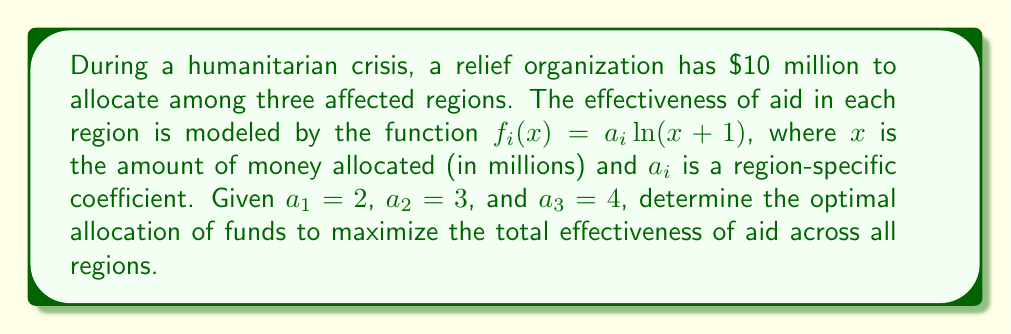Can you answer this question? To solve this problem, we'll use the method of Lagrange multipliers, as we're maximizing a function subject to a constraint.

1) Let $x$, $y$, and $z$ be the amounts allocated to regions 1, 2, and 3 respectively.

2) Our objective function is:
   $$f(x,y,z) = 2\ln(x+1) + 3\ln(y+1) + 4\ln(z+1)$$

3) Our constraint is:
   $$g(x,y,z) = x + y + z - 10 = 0$$

4) We form the Lagrangian:
   $$L(x,y,z,\lambda) = 2\ln(x+1) + 3\ln(y+1) + 4\ln(z+1) - \lambda(x + y + z - 10)$$

5) We take partial derivatives and set them to zero:
   $$\frac{\partial L}{\partial x} = \frac{2}{x+1} - \lambda = 0$$
   $$\frac{\partial L}{\partial y} = \frac{3}{y+1} - \lambda = 0$$
   $$\frac{\partial L}{\partial z} = \frac{4}{z+1} - \lambda = 0$$
   $$\frac{\partial L}{\partial \lambda} = x + y + z - 10 = 0$$

6) From these equations, we can deduce:
   $$\frac{2}{x+1} = \frac{3}{y+1} = \frac{4}{z+1} = \lambda$$

7) This implies:
   $$x+1 = \frac{2}{\lambda}, y+1 = \frac{3}{\lambda}, z+1 = \frac{4}{\lambda}$$

8) Substituting into the constraint equation:
   $$(\frac{2}{\lambda} - 1) + (\frac{3}{\lambda} - 1) + (\frac{4}{\lambda} - 1) = 10$$
   $$\frac{9}{\lambda} - 3 = 10$$
   $$\frac{9}{\lambda} = 13$$
   $$\lambda = \frac{9}{13}$$

9) Now we can solve for $x$, $y$, and $z$:
   $$x = \frac{2}{\lambda} - 1 = \frac{26}{9} - 1 = \frac{17}{9} \approx 1.89$$
   $$y = \frac{3}{\lambda} - 1 = \frac{39}{9} - 1 = \frac{30}{9} \approx 3.33$$
   $$z = \frac{4}{\lambda} - 1 = \frac{52}{9} - 1 = \frac{43}{9} \approx 4.78$$

10) We can verify that $x + y + z = 10$, as required.
Answer: The optimal allocation is approximately $1.89 million to region 1, $3.33 million to region 2, and $4.78 million to region 3. 